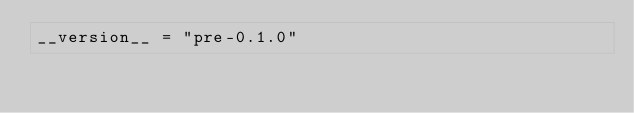<code> <loc_0><loc_0><loc_500><loc_500><_Python_>__version__ = "pre-0.1.0"
</code> 